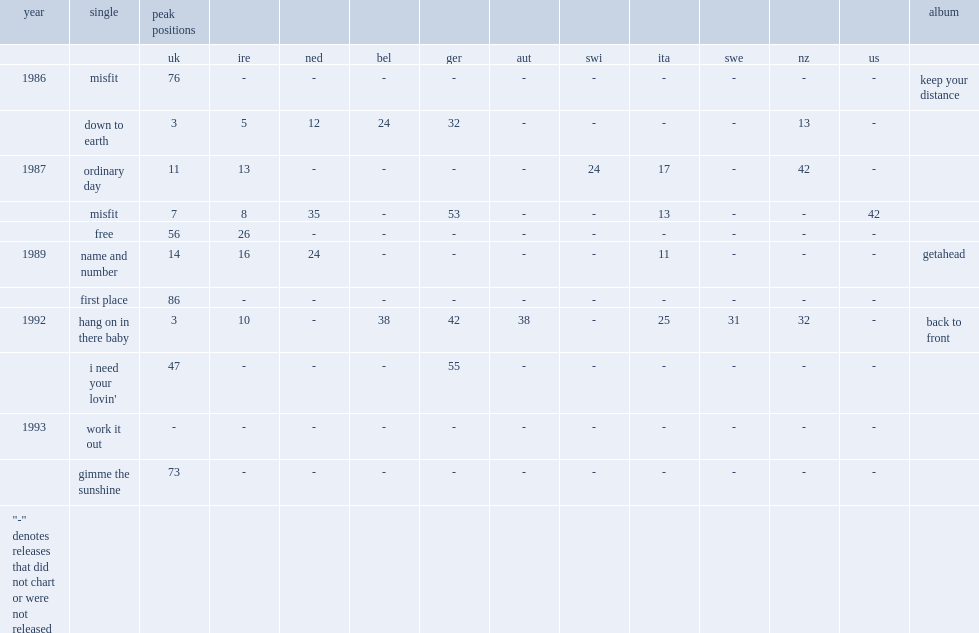When did the single "name and number" release? 1989.0. 